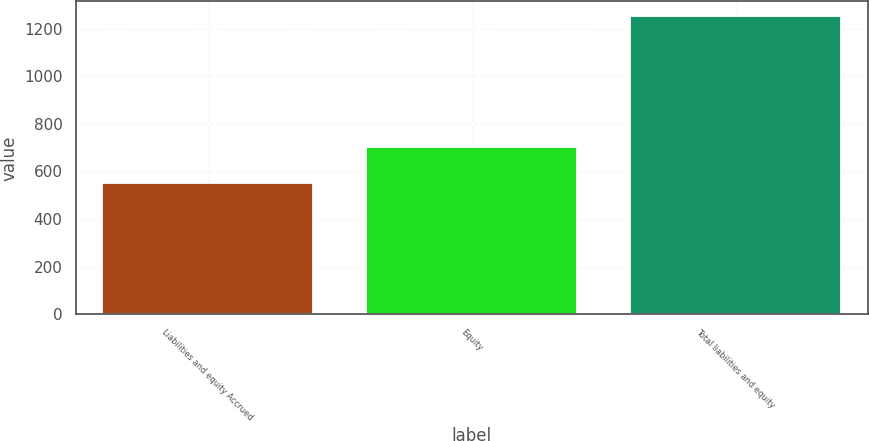<chart> <loc_0><loc_0><loc_500><loc_500><bar_chart><fcel>Liabilities and equity Accrued<fcel>Equity<fcel>Total liabilities and equity<nl><fcel>550<fcel>701<fcel>1251<nl></chart> 